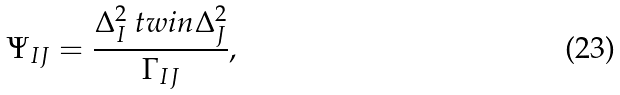Convert formula to latex. <formula><loc_0><loc_0><loc_500><loc_500>\Psi _ { I J } = \frac { \Delta _ { I } ^ { 2 } \ t w i n \Delta _ { J } ^ { 2 } } { \Gamma _ { I J } } ,</formula> 